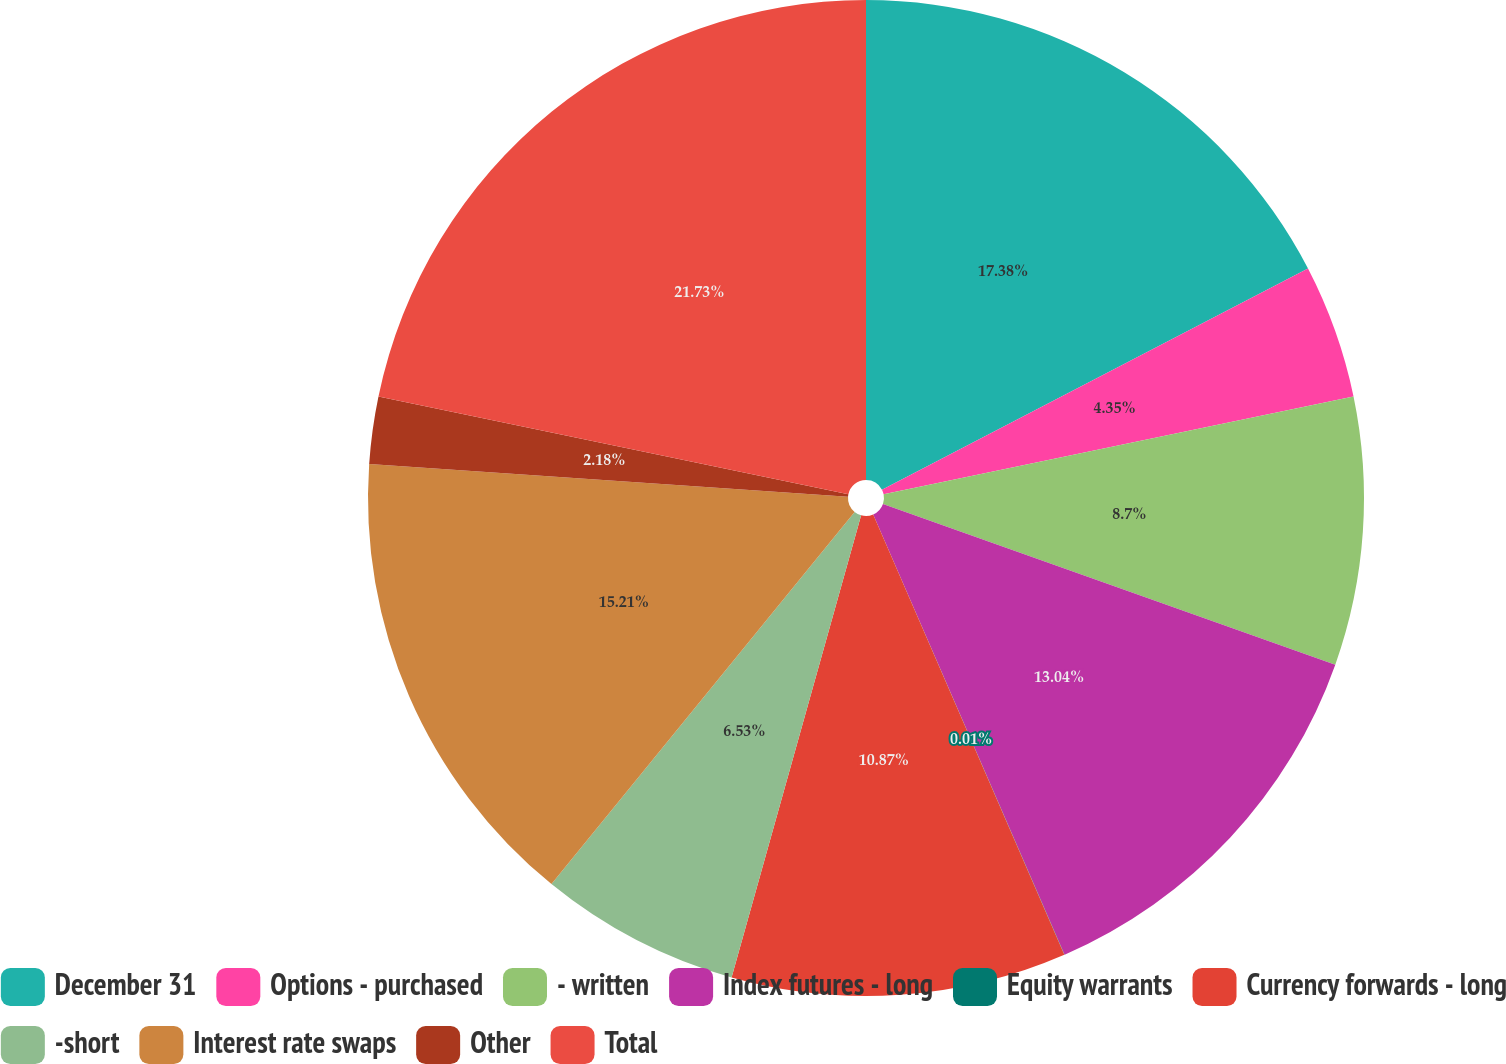Convert chart to OTSL. <chart><loc_0><loc_0><loc_500><loc_500><pie_chart><fcel>December 31<fcel>Options - purchased<fcel>- written<fcel>Index futures - long<fcel>Equity warrants<fcel>Currency forwards - long<fcel>-short<fcel>Interest rate swaps<fcel>Other<fcel>Total<nl><fcel>17.38%<fcel>4.35%<fcel>8.7%<fcel>13.04%<fcel>0.01%<fcel>10.87%<fcel>6.53%<fcel>15.21%<fcel>2.18%<fcel>21.73%<nl></chart> 